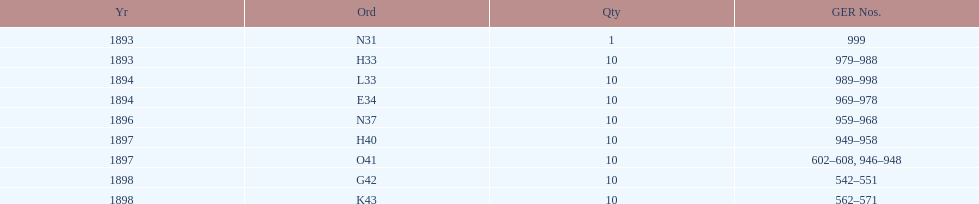How mans years have ger nos below 900? 2. 